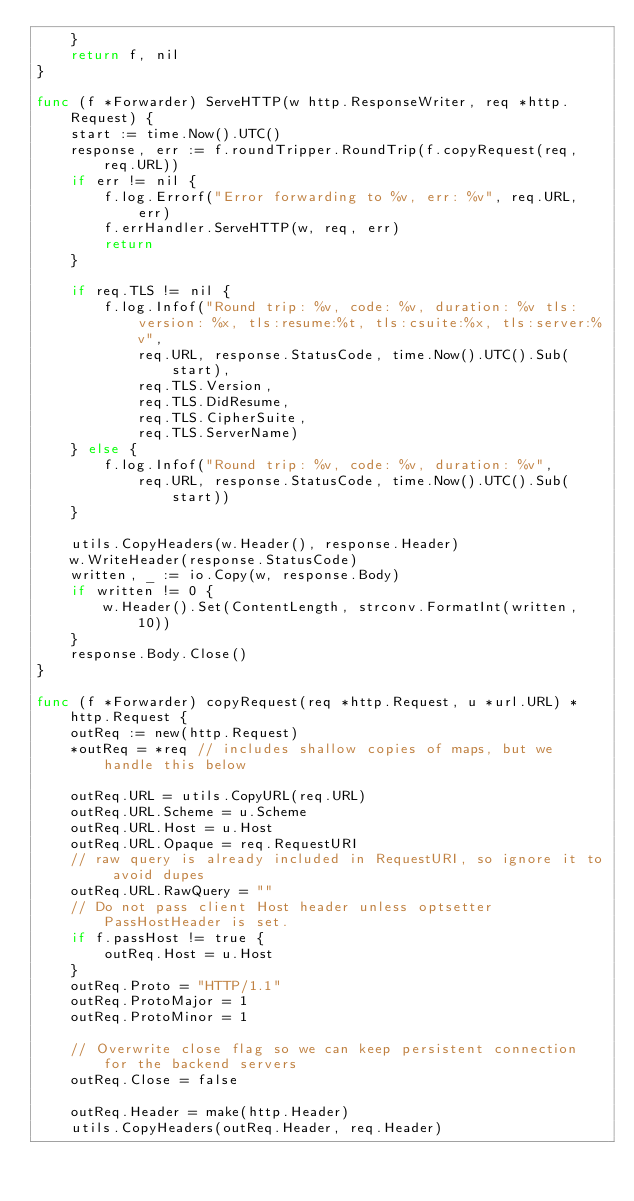Convert code to text. <code><loc_0><loc_0><loc_500><loc_500><_Go_>	}
	return f, nil
}

func (f *Forwarder) ServeHTTP(w http.ResponseWriter, req *http.Request) {
	start := time.Now().UTC()
	response, err := f.roundTripper.RoundTrip(f.copyRequest(req, req.URL))
	if err != nil {
		f.log.Errorf("Error forwarding to %v, err: %v", req.URL, err)
		f.errHandler.ServeHTTP(w, req, err)
		return
	}

	if req.TLS != nil {
		f.log.Infof("Round trip: %v, code: %v, duration: %v tls:version: %x, tls:resume:%t, tls:csuite:%x, tls:server:%v",
			req.URL, response.StatusCode, time.Now().UTC().Sub(start),
			req.TLS.Version,
			req.TLS.DidResume,
			req.TLS.CipherSuite,
			req.TLS.ServerName)
	} else {
		f.log.Infof("Round trip: %v, code: %v, duration: %v",
			req.URL, response.StatusCode, time.Now().UTC().Sub(start))
	}

	utils.CopyHeaders(w.Header(), response.Header)
	w.WriteHeader(response.StatusCode)
	written, _ := io.Copy(w, response.Body)
	if written != 0 {
		w.Header().Set(ContentLength, strconv.FormatInt(written, 10))
	}
	response.Body.Close()
}

func (f *Forwarder) copyRequest(req *http.Request, u *url.URL) *http.Request {
	outReq := new(http.Request)
	*outReq = *req // includes shallow copies of maps, but we handle this below

	outReq.URL = utils.CopyURL(req.URL)
	outReq.URL.Scheme = u.Scheme
	outReq.URL.Host = u.Host
	outReq.URL.Opaque = req.RequestURI
	// raw query is already included in RequestURI, so ignore it to avoid dupes
	outReq.URL.RawQuery = ""
	// Do not pass client Host header unless optsetter PassHostHeader is set.
	if f.passHost != true {
		outReq.Host = u.Host
	}
	outReq.Proto = "HTTP/1.1"
	outReq.ProtoMajor = 1
	outReq.ProtoMinor = 1

	// Overwrite close flag so we can keep persistent connection for the backend servers
	outReq.Close = false

	outReq.Header = make(http.Header)
	utils.CopyHeaders(outReq.Header, req.Header)
</code> 